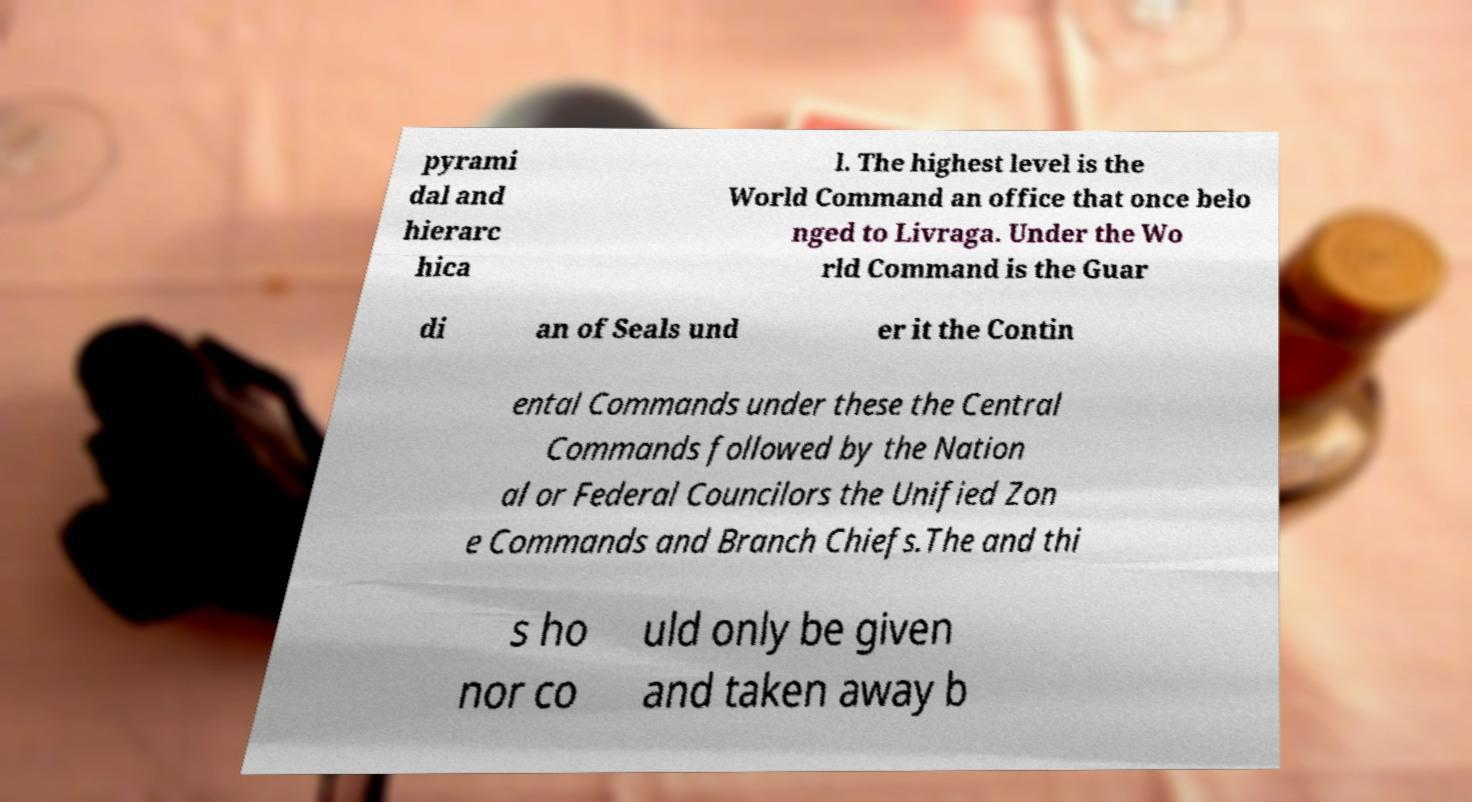For documentation purposes, I need the text within this image transcribed. Could you provide that? pyrami dal and hierarc hica l. The highest level is the World Command an office that once belo nged to Livraga. Under the Wo rld Command is the Guar di an of Seals und er it the Contin ental Commands under these the Central Commands followed by the Nation al or Federal Councilors the Unified Zon e Commands and Branch Chiefs.The and thi s ho nor co uld only be given and taken away b 